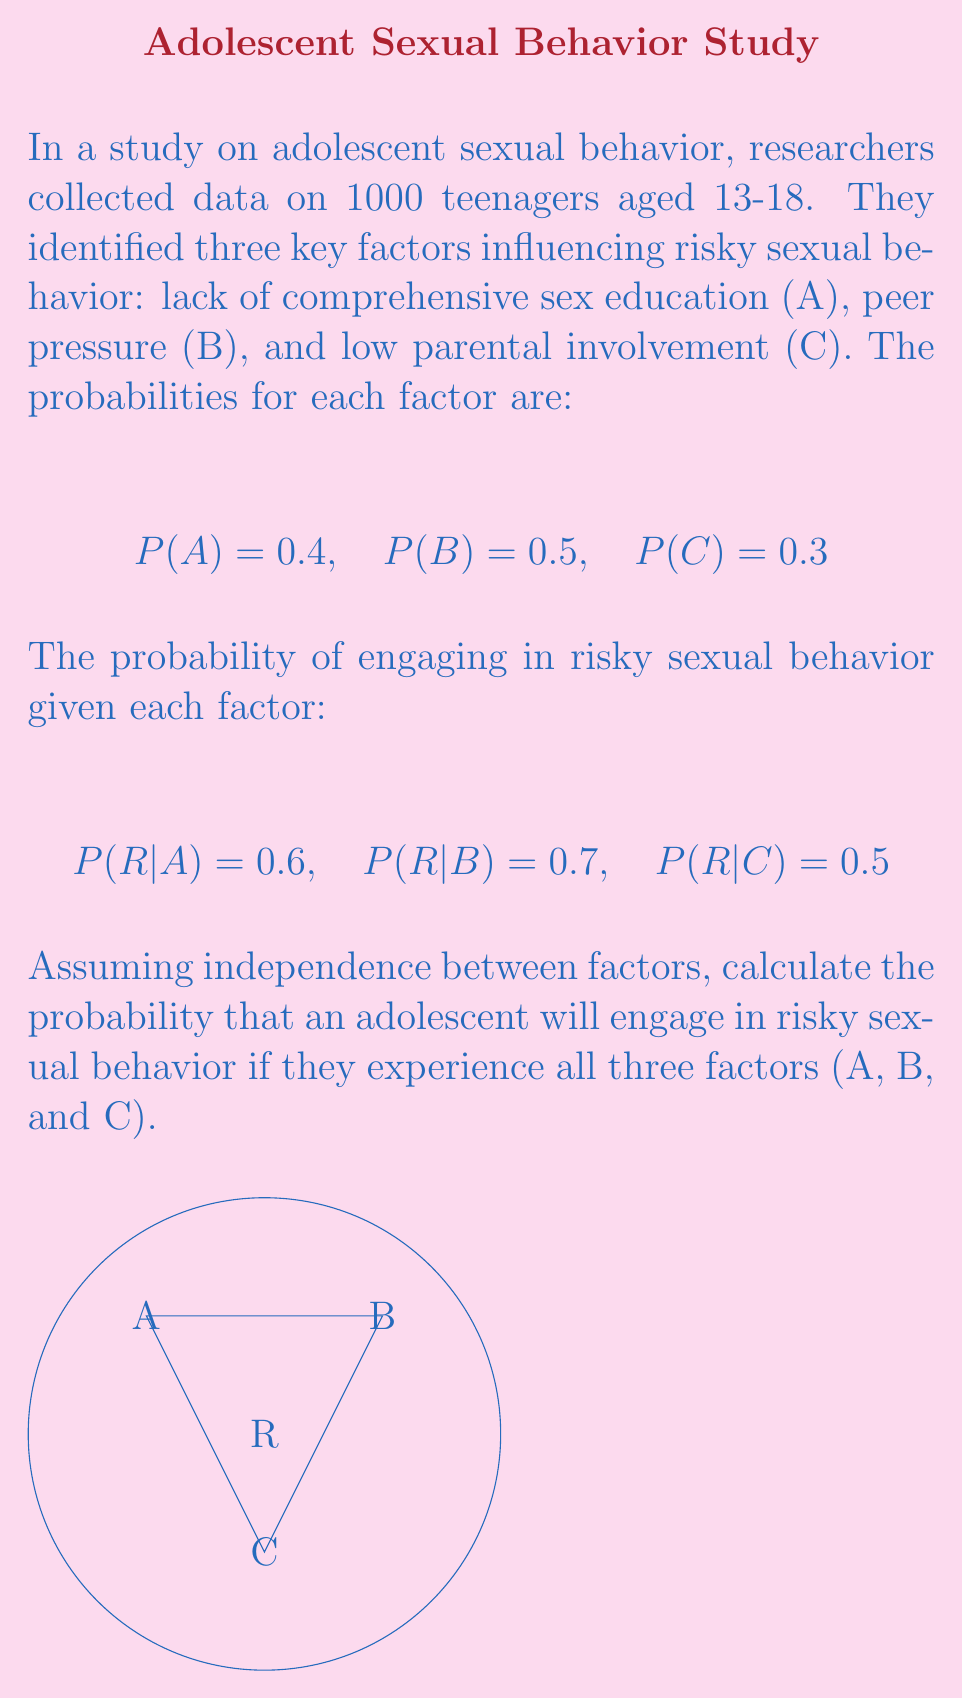Help me with this question. To solve this problem, we'll use the concept of conditional probability and the assumption of independence between factors.

Step 1: Calculate the probability of all three factors occurring together.
Since the factors are independent:
$$P(A \cap B \cap C) = P(A) \times P(B) \times P(C) = 0.4 \times 0.5 \times 0.3 = 0.06$$

Step 2: Calculate the probability of risky behavior given all three factors.
Using the conditional probability formula and independence assumption:
$$P(R|A \cap B \cap C) = P(R|A) \times P(R|B) \times P(R|C)$$
$$P(R|A \cap B \cap C) = 0.6 \times 0.7 \times 0.5 = 0.21$$

Step 3: Calculate the final probability using the multiplication rule of probability.
$$P(R \cap A \cap B \cap C) = P(A \cap B \cap C) \times P(R|A \cap B \cap C)$$
$$P(R \cap A \cap B \cap C) = 0.06 \times 0.21 = 0.0126$$

Therefore, the probability that an adolescent will engage in risky sexual behavior if they experience all three factors is 0.0126 or 1.26%.
Answer: 0.0126 or 1.26% 